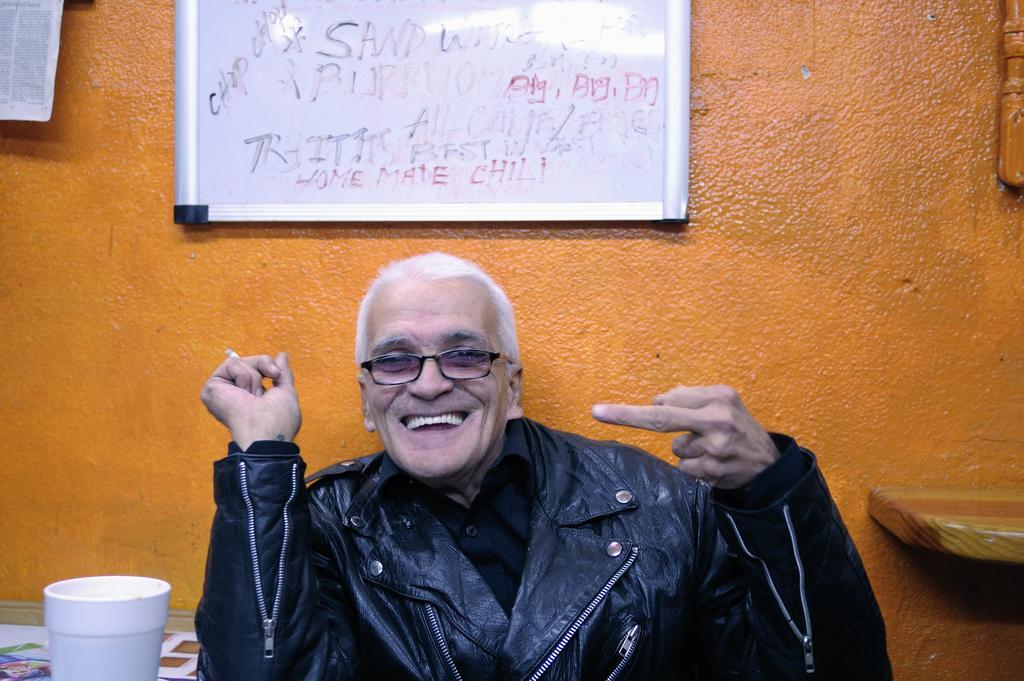Could you give a brief overview of what you see in this image? In this image there is a man he is wearing black color jacket, beside him there is a table, on that table there is a glass, in the background there is a wall to that wall there is a white board. 